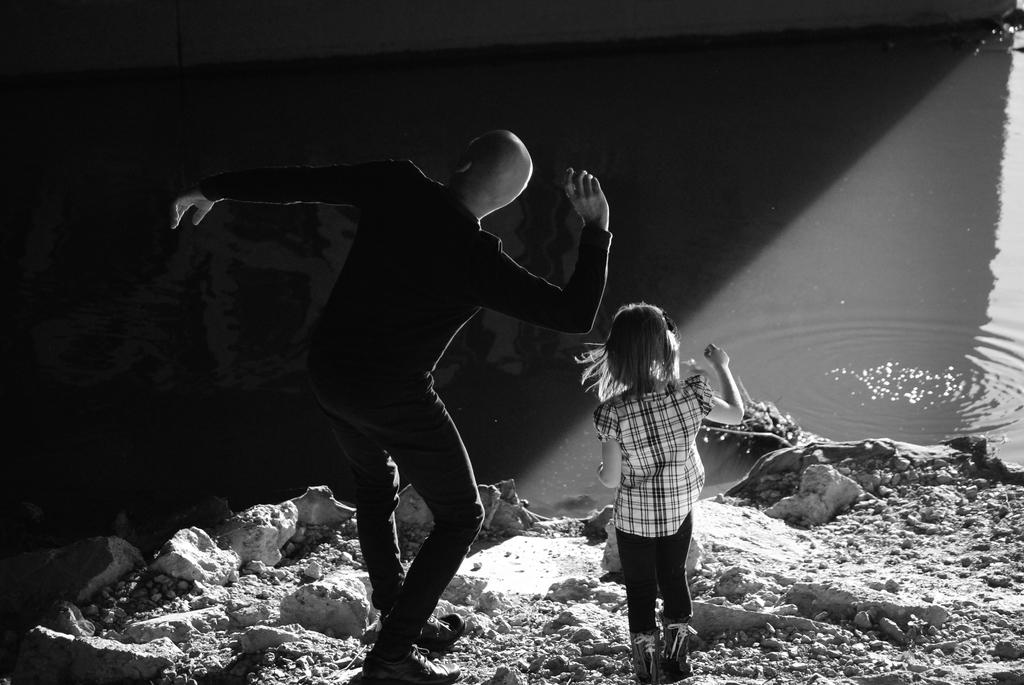What is the color scheme of the image? The image is black and white. Who can be seen in the image? There is a man and a kid in the image. What are the man and the kid doing in the image? The man and the kid are standing on a surface. What is in front of the man and the kid? There is water in front of the two persons. What type of attack is the man launching on the drawer in the image? There is no drawer present in the image, and the man is not launching any attack. Can you see any writing on the surface where the man and the kid are standing? There is no writing visible on the surface where the man and the kid are standing. 